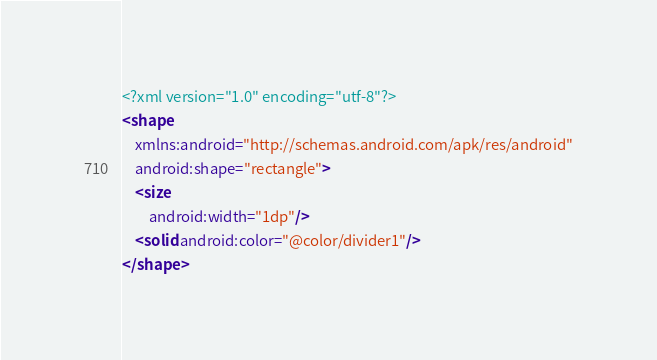<code> <loc_0><loc_0><loc_500><loc_500><_XML_><?xml version="1.0" encoding="utf-8"?>
<shape
    xmlns:android="http://schemas.android.com/apk/res/android"
    android:shape="rectangle">
    <size
        android:width="1dp"/>
    <solid android:color="@color/divider1"/>
</shape>
</code> 